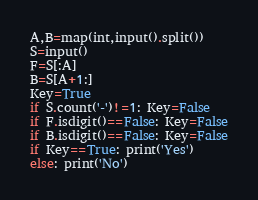Convert code to text. <code><loc_0><loc_0><loc_500><loc_500><_Python_>A,B=map(int,input().split())
S=input()
F=S[:A]
B=S[A+1:]
Key=True
if S.count('-')!=1: Key=False
if F.isdigit()==False: Key=False
if B.isdigit()==False: Key=False
if Key==True: print('Yes')
else: print('No')</code> 